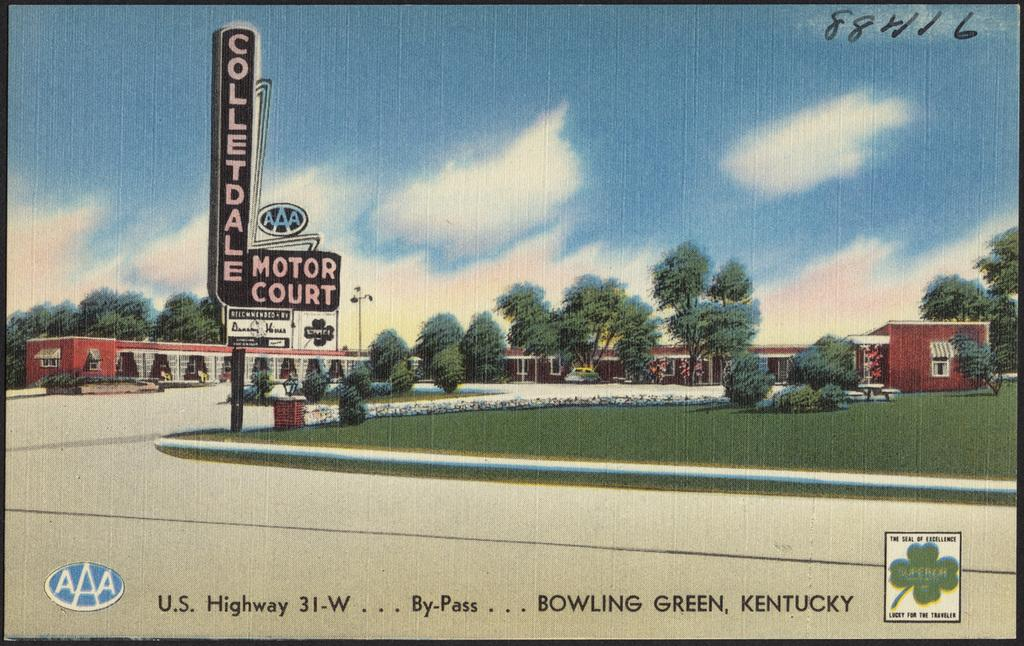<image>
Offer a succinct explanation of the picture presented. The picture is a display of business based in Bowling Green Kentucky. 